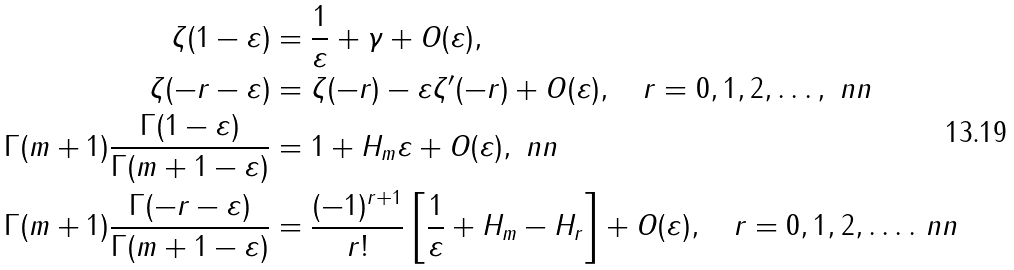<formula> <loc_0><loc_0><loc_500><loc_500>\zeta ( 1 - \varepsilon ) & = \frac { 1 } { \varepsilon } + \gamma + O ( \varepsilon ) , \\ \zeta ( - r - \varepsilon ) & = \zeta ( - r ) - \varepsilon \zeta ^ { \prime } ( - r ) + O ( \varepsilon ) , \quad r = 0 , 1 , 2 , \dots , \ n n \\ \Gamma ( m + 1 ) \frac { \Gamma ( 1 - \varepsilon ) } { \Gamma ( m + 1 - \varepsilon ) } & = 1 + H _ { m } \varepsilon + O ( \varepsilon ) , \ n n \\ \Gamma ( m + 1 ) \frac { \Gamma ( - r - \varepsilon ) } { \Gamma ( m + 1 - \varepsilon ) } & = \frac { { ( - 1 ) ^ { r + 1 } } } { r ! } \left [ { \frac { 1 } { \varepsilon } + H _ { m } - H _ { r } } \right ] + O ( \varepsilon ) , \quad r = 0 , 1 , 2 , \dots . \ n n</formula> 